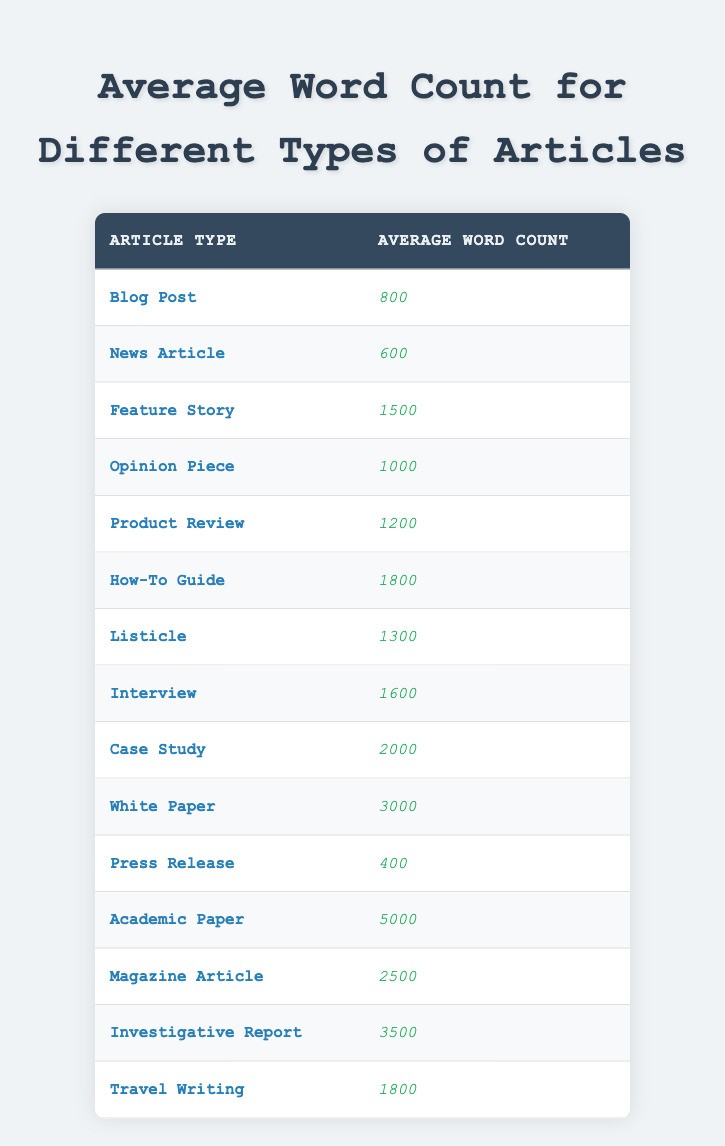What is the average word count for a Blog Post? The table lists the average word count for a Blog Post as 800. This value can be found directly in the corresponding row under the "Average Word Count" column.
Answer: 800 Which article type has the highest average word count? By examining the "Average Word Count" column, Academic Paper has the highest value at 5000, so it is the article type with the highest average.
Answer: Academic Paper How many article types have an average word count of 2000 or more? To find the answer, we need to count the article types listed in the table and check their average word counts. The article types with 2000 or more are: Case Study (2000), White Paper (3000), Academic Paper (5000), and Investigative Report (3500). That gives us a total of 4 article types.
Answer: 4 Is the average word count of a White Paper greater than that of a Feature Story? The average word count for a White Paper is 3000, while for a Feature Story, it is 1500. Since 3000 is greater than 1500, the statement is true.
Answer: Yes What is the difference in average word count between a How-To Guide and a Press Release? First, we find the average word counts: How-To Guide is 1800 and Press Release is 400. To find the difference, we subtract the Press Release count from the How-To Guide count: 1800 - 400 = 1400. Thus, the difference in average word count is 1400.
Answer: 1400 Which article types have an average word count between 1000 and 2000? We need to identify the article types in that range. The relevant article types are: Opinion Piece (1000), Product Review (1200), Listicle (1300), Interview (1600), and How-To Guide (1800). This gives us a total of 5 article types in this range.
Answer: 5 Is a Travel Writing article typically longer than a News Article? The average word count for Travel Writing is 1800, while for News Article it is 600. Since 1800 is greater than 600, the answer is yes.
Answer: Yes What is the average word count for other article types excluding Academic Paper? To find this, we sum the average word counts of all article types excluding Academic Paper. Adding the word counts from all article types listed and then dividing by the number of types (excluding Academic Paper, which leads us to 14 total article types) gives us an average of (800 + 600 + 1500 + 1000 + 1200 + 1800 + 1300 + 1600 + 2000 + 3000 + 400 + 2500 + 3500 + 1800) / 13 = 1750.
Answer: 1750 